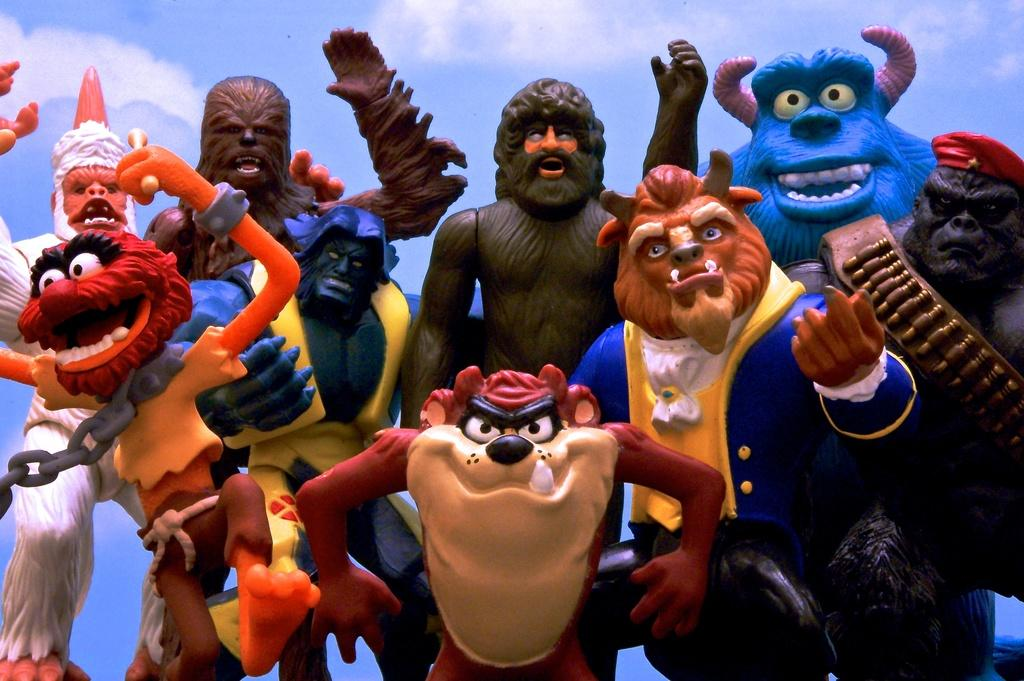What type of objects can be seen in the image? There are many toys in the image. What can be seen in the background of the image? The sky is visible behind the toys in the image. What type of copper material is used to make the rifle in the image? There is no rifle present in the image, and therefore no copper material can be observed. 